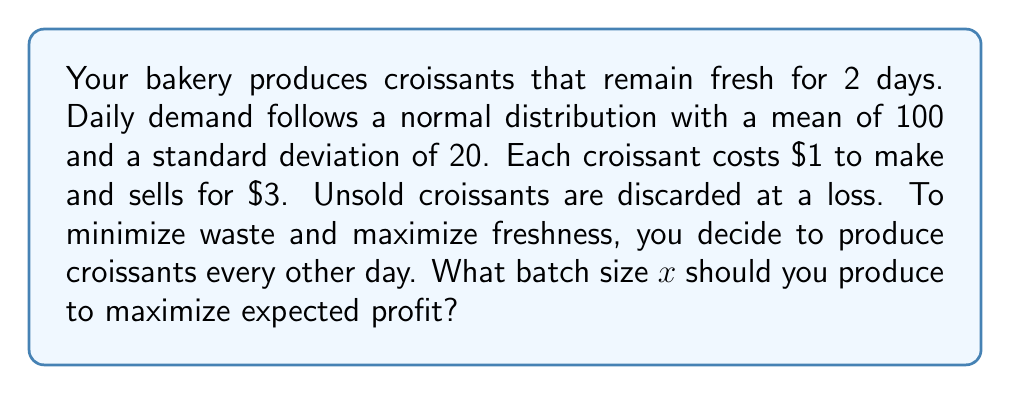Help me with this question. Let's approach this step-by-step:

1) First, we need to determine the probability distribution for the two-day demand. Since daily demand is normally distributed with mean 100 and standard deviation 20, the two-day demand will be normally distributed with:

   Mean: $\mu = 100 * 2 = 200$
   Standard deviation: $\sigma = 20 * \sqrt{2} \approx 28.28$

2) Let $f(x)$ be the probability density function of this normal distribution:

   $$f(x) = \frac{1}{\sigma\sqrt{2\pi}} e^{-\frac{1}{2}\left(\frac{x-\mu}{\sigma}\right)^2}$$

3) The expected profit function $E(P)$ can be expressed as:

   $$E(P) = 3\int_0^x yf(y)dy + 3x\int_x^\infty f(y)dy - x$$

   Where:
   - $3\int_0^x yf(y)dy$ represents the revenue from selling when demand is less than supply
   - $3x\int_x^\infty f(y)dy$ represents the revenue from selling when demand exceeds supply
   - $x$ represents the cost of producing $x$ croissants

4) To maximize $E(P)$, we need to find where its derivative equals zero:

   $$\frac{d}{dx}E(P) = 3xf(x) + 3\int_x^\infty f(y)dy - 3xf(x) - 1 = 0$$

5) Simplifying:

   $$\int_x^\infty f(y)dy = \frac{1}{3}$$

6) This integral represents the probability that demand exceeds $x$. In a normal distribution, this is equivalent to:

   $$1 - \Phi\left(\frac{x-\mu}{\sigma}\right) = \frac{1}{3}$$

   Where $\Phi$ is the cumulative distribution function of the standard normal distribution.

7) Solving this equation:

   $$\Phi\left(\frac{x-\mu}{\sigma}\right) = \frac{2}{3}$$

   $$\frac{x-\mu}{\sigma} = \Phi^{-1}\left(\frac{2}{3}\right) \approx 0.4307$$

8) Substituting the values of $\mu$ and $\sigma$:

   $$\frac{x-200}{28.28} \approx 0.4307$$

9) Solving for $x$:

   $$x \approx 200 + 0.4307 * 28.28 \approx 212.18$$

Therefore, the optimal batch size is approximately 212 croissants.
Answer: 212 croissants 